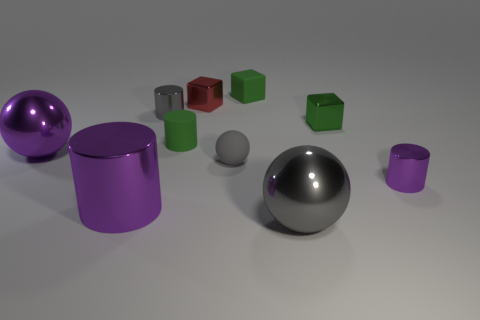What color is the small cylinder in front of the large purple metal ball?
Your answer should be very brief. Purple. Do the block that is in front of the red object and the metal block behind the gray cylinder have the same size?
Provide a succinct answer. Yes. What number of things are large brown shiny objects or small blocks?
Make the answer very short. 3. What is the material of the thing behind the red metallic block that is left of the small gray ball?
Your answer should be very brief. Rubber. What number of other small objects are the same shape as the small purple thing?
Give a very brief answer. 2. Is there another cylinder that has the same color as the large cylinder?
Keep it short and to the point. Yes. How many objects are either tiny purple things that are on the right side of the big cylinder or small cylinders that are in front of the large purple shiny sphere?
Provide a succinct answer. 1. Are there any purple things that are right of the gray sphere on the left side of the small rubber block?
Your answer should be very brief. Yes. What shape is the green matte thing that is the same size as the green rubber block?
Make the answer very short. Cylinder. How many objects are either cylinders behind the large cylinder or large purple metallic things?
Keep it short and to the point. 5. 